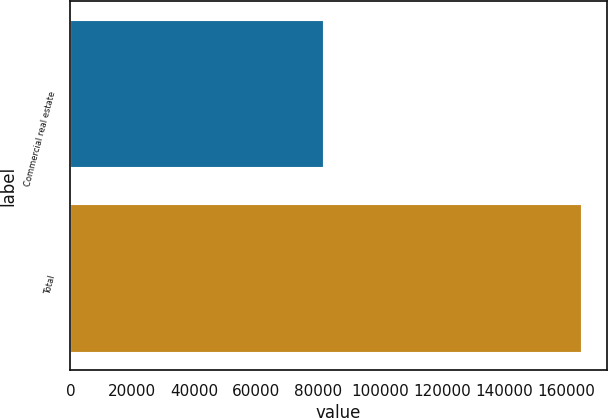Convert chart. <chart><loc_0><loc_0><loc_500><loc_500><bar_chart><fcel>Commercial real estate<fcel>Total<nl><fcel>81475<fcel>164853<nl></chart> 